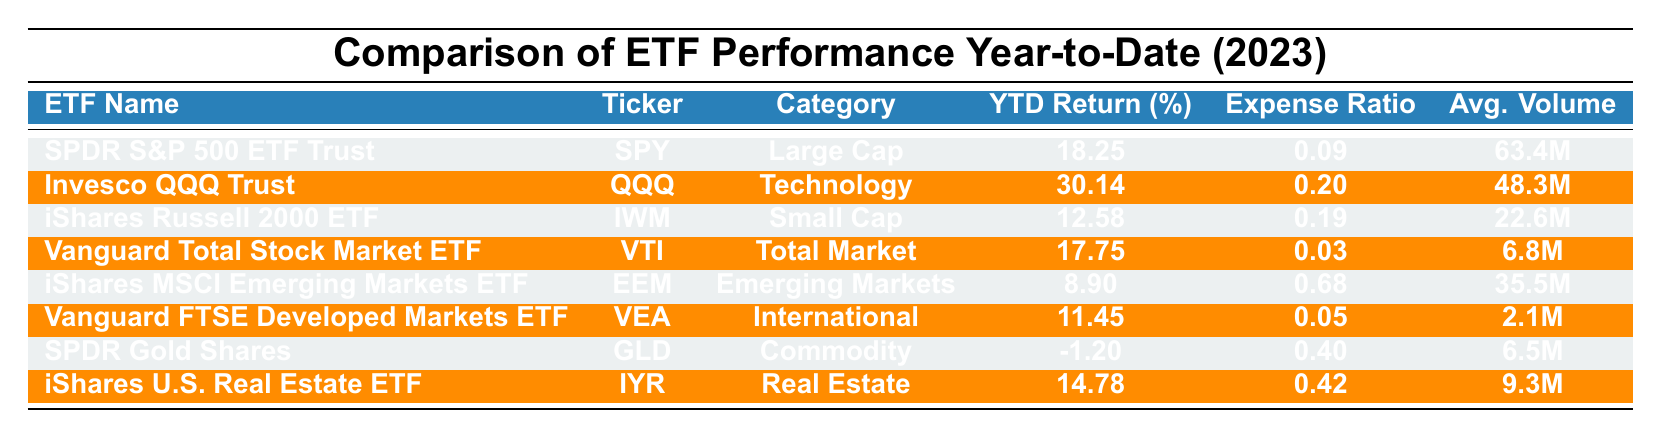What is the YTD return percentage for the Invesco QQQ Trust? The table shows that the YTD return percentage for the Invesco QQQ Trust (ticker QQQ) is listed under the YTD Return column. It states "30.14" for this ETF.
Answer: 30.14 Which ETF has the lowest YTD return percentage? By examining the YTD Return column, the lowest value is "-1.20," which corresponds to SPDR Gold Shares (ticker GLD).
Answer: SPDR Gold Shares What is the average expense ratio of the ETFs listed in the table? To find the average expense ratio, first sum the expense ratios: 0.09 + 0.20 + 0.19 + 0.03 + 0.68 + 0.05 + 0.40 + 0.42 = 2.06. Then divide by the number of ETFs, which is 8: 2.06 / 8 = 0.2575, rounded to two decimal places is 0.26.
Answer: 0.26 Is the Vanguard Total Stock Market ETF in the Technology category? The table indicates that the Vanguard Total Stock Market ETF (ticker VTI) is categorized under "Total Market," not Technology.
Answer: No Which ETF has both a YTD return greater than 25% and an expense ratio lower than 0.10? From the YTD Returns, only the Invesco QQQ Trust has a YTD return of 30.14%, but its expense ratio is 0.20, which doesn't meet the requirement. Therefore, there are no ETFs meeting both criteria.
Answer: None How many ETFs have a YTD return percentage greater than 15%? The ETFs with a YTD return greater than 15% are SPDR S&P 500 ETF Trust (18.25%), Invesco QQQ Trust (30.14%), and iShares U.S. Real Estate ETF (14.78%). This adds up to three ETFs.
Answer: 3 What is the percentage difference between the YTD returns of the Invesco QQQ Trust and the iShares Russell 2000 ETF? The YTD return for QQQ is 30.14% and for IWM is 12.58%. The difference is 30.14 - 12.58 = 17.56%. Thus, the percentage difference is 17.56%.
Answer: 17.56% Which category has the highest average trading volume among the ETFs listed? The average trading volume can be derived from the volume data: SPY (63.4M), QQQ (48.3M), IWM (22.6M), VTI (6.8M), IEM (35.5M), VEA (2.1M), GLD (6.5M), IYR (9.3M). Highest is SPDR S&P 500 ETF Trust with 63.4M volume.
Answer: Large Cap How does the YTD return of the iShares MSCI Emerging Markets ETF compare to the Vanguard FTSE Developed Markets ETF? The iShares MSCI Emerging Markets ETF has a YTD return of 8.90%, while the Vanguard FTSE Developed Markets ETF has 11.45%. 11.45% is greater than 8.90%.
Answer: Vanguard FTSE Developed Markets ETF has a higher YTD return 